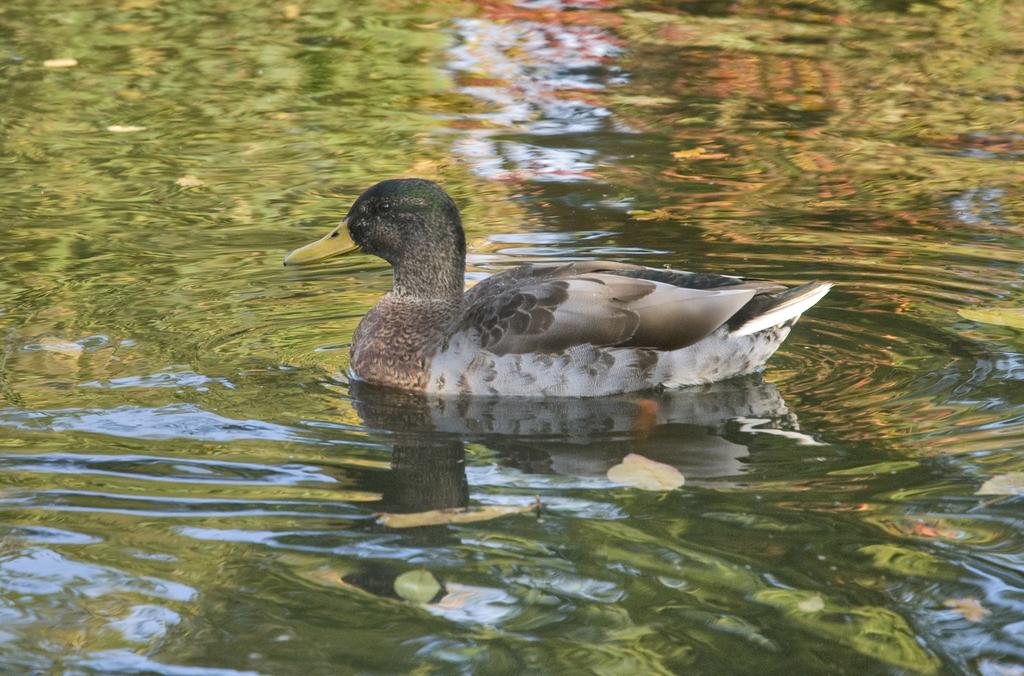What animal is present in the image? There is a duck in the image. Where is the duck located? The duck is in the water. What else can be seen in the water in the image? There are leaves in the water. How many bushes are visible in the image? There is no mention of bushes in the provided facts, so it cannot be determined how many bushes are visible in the image. Can you tell me where the deer is located in the image? There is no deer present in the image. What type of judgment is the judge making in the image? There is no judge or any indication of a judgment being made in the image. 